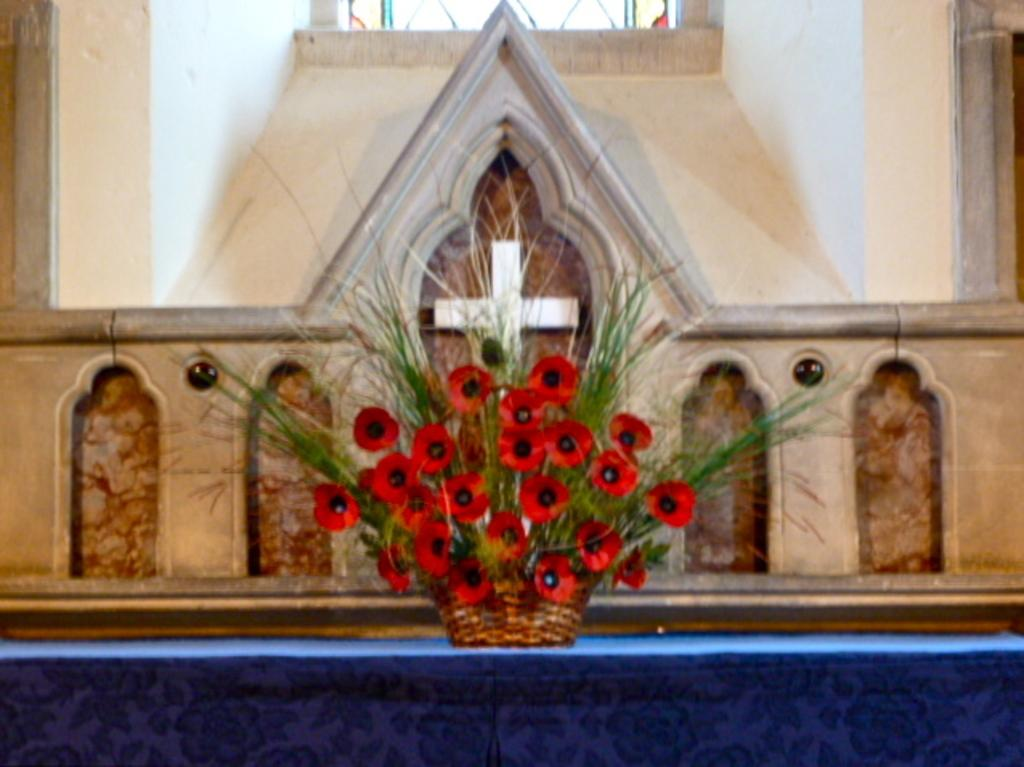What object is placed on the table in the image? There is a flower pot on the table. What can be seen behind the flower pot? There is a wall behind the flower pot. What is depicted on the wall? There is a cross on the wall. Is there a cobweb hanging from the cross in the image? There is no mention of a cobweb in the image, so we cannot determine if one is present or not. 